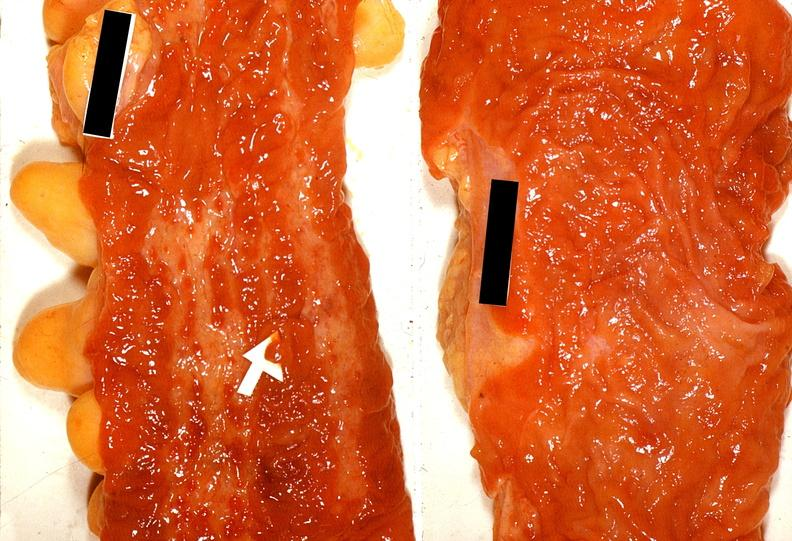where does this belong to?
Answer the question using a single word or phrase. Gastrointestinal system 